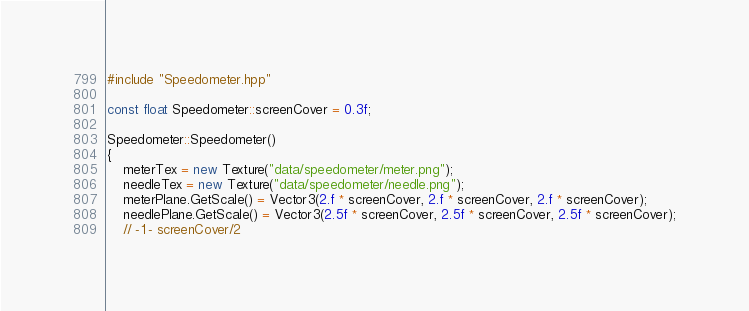<code> <loc_0><loc_0><loc_500><loc_500><_C++_>#include "Speedometer.hpp"

const float Speedometer::screenCover = 0.3f;

Speedometer::Speedometer()
{
    meterTex = new Texture("data/speedometer/meter.png");
    needleTex = new Texture("data/speedometer/needle.png");
    meterPlane.GetScale() = Vector3(2.f * screenCover, 2.f * screenCover, 2.f * screenCover);
    needlePlane.GetScale() = Vector3(2.5f * screenCover, 2.5f * screenCover, 2.5f * screenCover);
    // -1 - screenCover/2</code> 